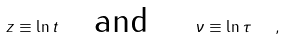Convert formula to latex. <formula><loc_0><loc_0><loc_500><loc_500>z \equiv \ln { t } \quad \text {and} \quad \ \nu \equiv \ln \tau \ \ ,</formula> 